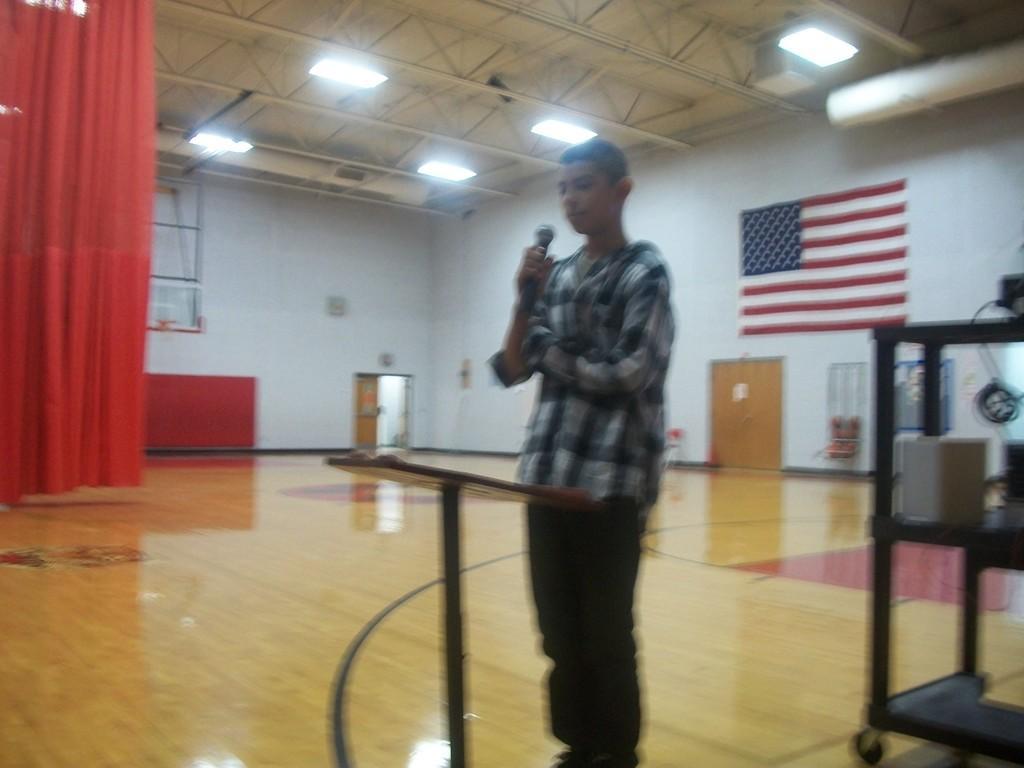Describe this image in one or two sentences. A boy is standing in a hall holding a microphone. There is a table, red curtains at the left. There are doors and US flag on the wall. There is a wooden surface. There are lights on the top. 